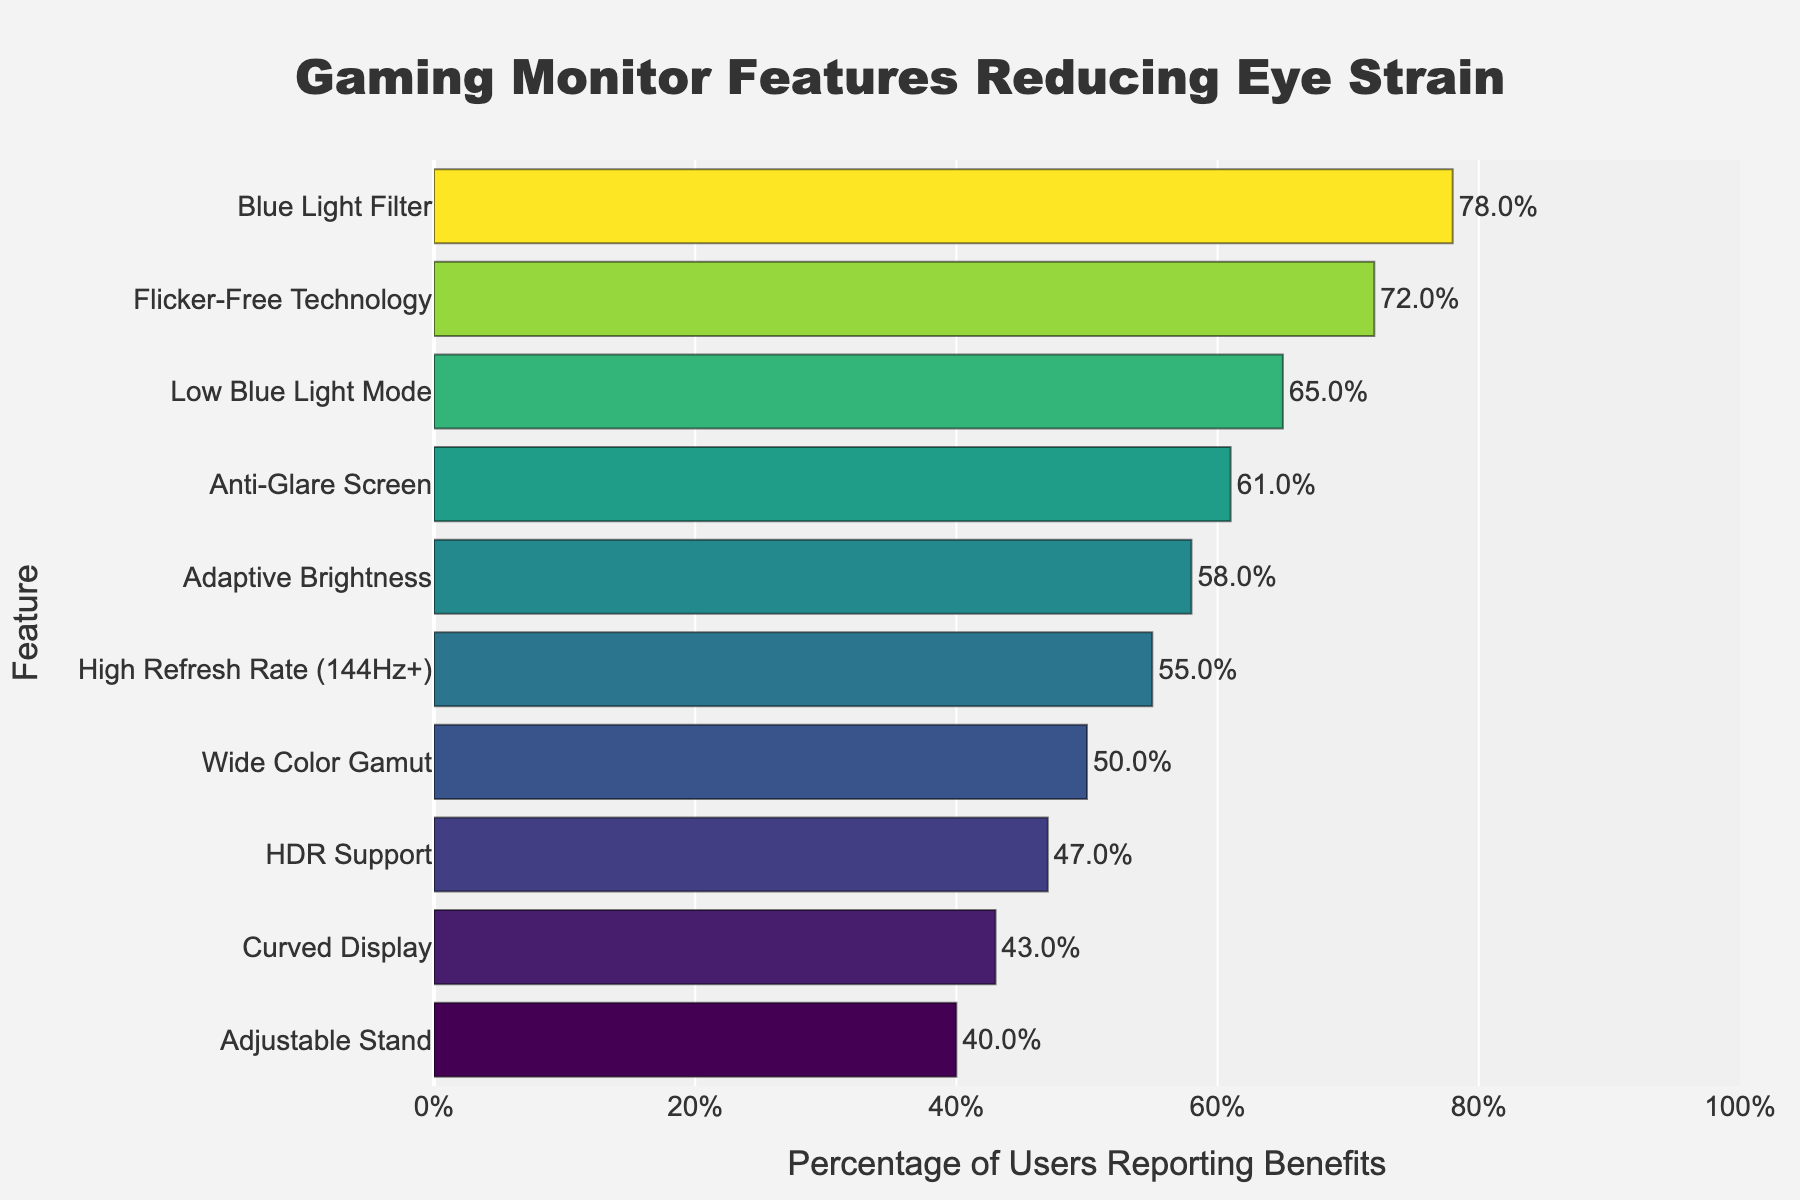What feature has the highest percentage of users reporting benefits? The feature with the highest percentage can be identified by looking at the top-most or the longest bar in the chart. The "Blue Light Filter" feature has the highest bar with 78% of users reporting benefits.
Answer: Blue Light Filter How many features have a percentage of users reporting benefits above 60%? Look for the bars that extend past the 60% mark on the x-axis. Counting these features gives us "Blue Light Filter," "Flicker-Free Technology," "Low Blue Light Mode," and "Anti-Glare Screen," making a total of four features.
Answer: 4 Which feature has the lowest percentage of users reporting benefits, and what is this percentage? The feature with the lowest percentage can be identified by looking at the bottom-most or the shortest bar in the chart. The "Adjustable Stand" has the lowest bar with 40% of users reporting benefits.
Answer: Adjustable Stand, 40% How much greater is the percentage of users reporting benefits for "Flicker-Free Technology" compared to "Adjustable Stand"? Subtract the percentage for "Adjustable Stand" from the percentage for "Flicker-Free Technology" to find the difference. 72% - 40% = 32%.
Answer: 32% What is the percentage difference between "High Refresh Rate (144Hz+)" and "Curved Display"? Subtract the percentage of users reporting benefits for "Curved Display" from that of "High Refresh Rate (144Hz+)". 55% - 43% = 12%.
Answer: 12% What is the sum of the percentages of users reporting benefits for "Adaptive Brightness" and "HDR Support"? Add the percentages for both features together. 58% + 47% = 105%.
Answer: 105% Which feature ranks third in terms of the percentage of users reporting benefits, and what is that percentage? Identify the third highest bar on the y-axis to find the third ranking feature. "Low Blue Light Mode" is the third highest with 65%.
Answer: Low Blue Light Mode, 65% What is the average percentage of users reporting benefits for all features listed? Sum all the percentage values and divide by the total number of features. (78 + 72 + 65 + 61 + 58 + 55 + 50 + 47 + 43 + 40) / 10 = 56.9%.
Answer: 56.9% Are there any features where less than 50% of users reported benefits? If yes, which ones? Look for bars that do not extend past the 50% mark on the x-axis. The features are "HDR Support", "Curved Display", and "Adjustable Stand".
Answer: HDR Support, Curved Display, Adjustable Stand What is the median percentage of users reporting benefits for these features? First, list the percentages in ascending order: 40, 43, 47, 50, 55, 58, 61, 65, 72, 78. With 10 values, the median is the average of the 5th and 6th values. (55 + 58) / 2 = 56.5%.
Answer: 56.5% 